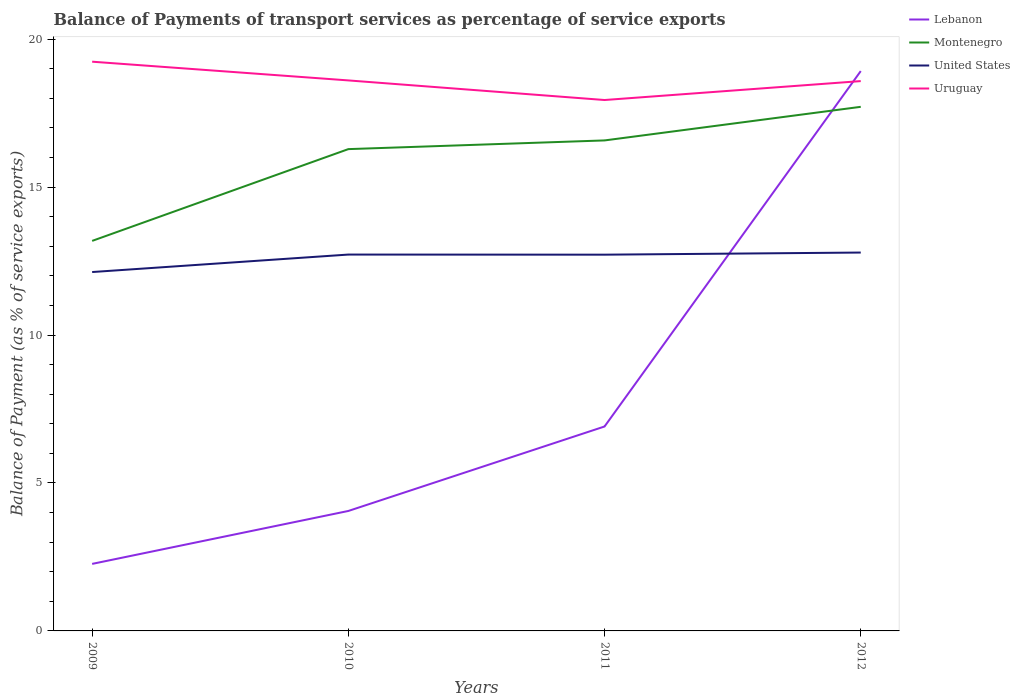Does the line corresponding to Montenegro intersect with the line corresponding to United States?
Your response must be concise. No. Is the number of lines equal to the number of legend labels?
Offer a very short reply. Yes. Across all years, what is the maximum balance of payments of transport services in Uruguay?
Keep it short and to the point. 17.94. In which year was the balance of payments of transport services in Montenegro maximum?
Your answer should be compact. 2009. What is the total balance of payments of transport services in Montenegro in the graph?
Your answer should be compact. -1.14. What is the difference between the highest and the second highest balance of payments of transport services in Montenegro?
Provide a short and direct response. 4.53. Is the balance of payments of transport services in Montenegro strictly greater than the balance of payments of transport services in Uruguay over the years?
Ensure brevity in your answer.  Yes. Are the values on the major ticks of Y-axis written in scientific E-notation?
Your answer should be compact. No. Does the graph contain any zero values?
Ensure brevity in your answer.  No. Does the graph contain grids?
Keep it short and to the point. No. Where does the legend appear in the graph?
Ensure brevity in your answer.  Top right. How many legend labels are there?
Offer a very short reply. 4. What is the title of the graph?
Your response must be concise. Balance of Payments of transport services as percentage of service exports. What is the label or title of the X-axis?
Your answer should be very brief. Years. What is the label or title of the Y-axis?
Provide a succinct answer. Balance of Payment (as % of service exports). What is the Balance of Payment (as % of service exports) of Lebanon in 2009?
Offer a very short reply. 2.27. What is the Balance of Payment (as % of service exports) of Montenegro in 2009?
Provide a short and direct response. 13.18. What is the Balance of Payment (as % of service exports) in United States in 2009?
Ensure brevity in your answer.  12.13. What is the Balance of Payment (as % of service exports) of Uruguay in 2009?
Offer a very short reply. 19.24. What is the Balance of Payment (as % of service exports) of Lebanon in 2010?
Provide a short and direct response. 4.05. What is the Balance of Payment (as % of service exports) of Montenegro in 2010?
Offer a terse response. 16.28. What is the Balance of Payment (as % of service exports) in United States in 2010?
Offer a very short reply. 12.72. What is the Balance of Payment (as % of service exports) of Uruguay in 2010?
Offer a very short reply. 18.61. What is the Balance of Payment (as % of service exports) of Lebanon in 2011?
Provide a succinct answer. 6.91. What is the Balance of Payment (as % of service exports) in Montenegro in 2011?
Offer a terse response. 16.58. What is the Balance of Payment (as % of service exports) of United States in 2011?
Give a very brief answer. 12.72. What is the Balance of Payment (as % of service exports) of Uruguay in 2011?
Give a very brief answer. 17.94. What is the Balance of Payment (as % of service exports) of Lebanon in 2012?
Keep it short and to the point. 18.92. What is the Balance of Payment (as % of service exports) of Montenegro in 2012?
Your answer should be very brief. 17.71. What is the Balance of Payment (as % of service exports) of United States in 2012?
Provide a short and direct response. 12.79. What is the Balance of Payment (as % of service exports) of Uruguay in 2012?
Give a very brief answer. 18.58. Across all years, what is the maximum Balance of Payment (as % of service exports) of Lebanon?
Offer a terse response. 18.92. Across all years, what is the maximum Balance of Payment (as % of service exports) in Montenegro?
Provide a succinct answer. 17.71. Across all years, what is the maximum Balance of Payment (as % of service exports) of United States?
Your answer should be very brief. 12.79. Across all years, what is the maximum Balance of Payment (as % of service exports) of Uruguay?
Provide a short and direct response. 19.24. Across all years, what is the minimum Balance of Payment (as % of service exports) of Lebanon?
Your answer should be very brief. 2.27. Across all years, what is the minimum Balance of Payment (as % of service exports) of Montenegro?
Your answer should be very brief. 13.18. Across all years, what is the minimum Balance of Payment (as % of service exports) in United States?
Give a very brief answer. 12.13. Across all years, what is the minimum Balance of Payment (as % of service exports) of Uruguay?
Make the answer very short. 17.94. What is the total Balance of Payment (as % of service exports) in Lebanon in the graph?
Offer a very short reply. 32.15. What is the total Balance of Payment (as % of service exports) of Montenegro in the graph?
Offer a very short reply. 63.76. What is the total Balance of Payment (as % of service exports) of United States in the graph?
Provide a succinct answer. 50.35. What is the total Balance of Payment (as % of service exports) in Uruguay in the graph?
Provide a succinct answer. 74.37. What is the difference between the Balance of Payment (as % of service exports) of Lebanon in 2009 and that in 2010?
Keep it short and to the point. -1.79. What is the difference between the Balance of Payment (as % of service exports) of Montenegro in 2009 and that in 2010?
Offer a terse response. -3.1. What is the difference between the Balance of Payment (as % of service exports) of United States in 2009 and that in 2010?
Keep it short and to the point. -0.59. What is the difference between the Balance of Payment (as % of service exports) in Uruguay in 2009 and that in 2010?
Your response must be concise. 0.63. What is the difference between the Balance of Payment (as % of service exports) in Lebanon in 2009 and that in 2011?
Give a very brief answer. -4.64. What is the difference between the Balance of Payment (as % of service exports) of Montenegro in 2009 and that in 2011?
Ensure brevity in your answer.  -3.4. What is the difference between the Balance of Payment (as % of service exports) in United States in 2009 and that in 2011?
Ensure brevity in your answer.  -0.59. What is the difference between the Balance of Payment (as % of service exports) in Uruguay in 2009 and that in 2011?
Provide a succinct answer. 1.3. What is the difference between the Balance of Payment (as % of service exports) in Lebanon in 2009 and that in 2012?
Provide a short and direct response. -16.66. What is the difference between the Balance of Payment (as % of service exports) in Montenegro in 2009 and that in 2012?
Make the answer very short. -4.53. What is the difference between the Balance of Payment (as % of service exports) in United States in 2009 and that in 2012?
Give a very brief answer. -0.66. What is the difference between the Balance of Payment (as % of service exports) of Uruguay in 2009 and that in 2012?
Your answer should be compact. 0.66. What is the difference between the Balance of Payment (as % of service exports) of Lebanon in 2010 and that in 2011?
Your answer should be compact. -2.85. What is the difference between the Balance of Payment (as % of service exports) in Montenegro in 2010 and that in 2011?
Your answer should be very brief. -0.29. What is the difference between the Balance of Payment (as % of service exports) in United States in 2010 and that in 2011?
Provide a succinct answer. 0. What is the difference between the Balance of Payment (as % of service exports) of Uruguay in 2010 and that in 2011?
Your answer should be compact. 0.66. What is the difference between the Balance of Payment (as % of service exports) of Lebanon in 2010 and that in 2012?
Give a very brief answer. -14.87. What is the difference between the Balance of Payment (as % of service exports) of Montenegro in 2010 and that in 2012?
Give a very brief answer. -1.43. What is the difference between the Balance of Payment (as % of service exports) in United States in 2010 and that in 2012?
Your answer should be very brief. -0.07. What is the difference between the Balance of Payment (as % of service exports) of Uruguay in 2010 and that in 2012?
Provide a short and direct response. 0.02. What is the difference between the Balance of Payment (as % of service exports) in Lebanon in 2011 and that in 2012?
Make the answer very short. -12.01. What is the difference between the Balance of Payment (as % of service exports) in Montenegro in 2011 and that in 2012?
Your answer should be very brief. -1.14. What is the difference between the Balance of Payment (as % of service exports) in United States in 2011 and that in 2012?
Provide a short and direct response. -0.07. What is the difference between the Balance of Payment (as % of service exports) of Uruguay in 2011 and that in 2012?
Offer a very short reply. -0.64. What is the difference between the Balance of Payment (as % of service exports) of Lebanon in 2009 and the Balance of Payment (as % of service exports) of Montenegro in 2010?
Provide a succinct answer. -14.02. What is the difference between the Balance of Payment (as % of service exports) in Lebanon in 2009 and the Balance of Payment (as % of service exports) in United States in 2010?
Keep it short and to the point. -10.45. What is the difference between the Balance of Payment (as % of service exports) of Lebanon in 2009 and the Balance of Payment (as % of service exports) of Uruguay in 2010?
Offer a very short reply. -16.34. What is the difference between the Balance of Payment (as % of service exports) in Montenegro in 2009 and the Balance of Payment (as % of service exports) in United States in 2010?
Keep it short and to the point. 0.46. What is the difference between the Balance of Payment (as % of service exports) in Montenegro in 2009 and the Balance of Payment (as % of service exports) in Uruguay in 2010?
Give a very brief answer. -5.42. What is the difference between the Balance of Payment (as % of service exports) of United States in 2009 and the Balance of Payment (as % of service exports) of Uruguay in 2010?
Make the answer very short. -6.48. What is the difference between the Balance of Payment (as % of service exports) of Lebanon in 2009 and the Balance of Payment (as % of service exports) of Montenegro in 2011?
Your answer should be compact. -14.31. What is the difference between the Balance of Payment (as % of service exports) of Lebanon in 2009 and the Balance of Payment (as % of service exports) of United States in 2011?
Keep it short and to the point. -10.45. What is the difference between the Balance of Payment (as % of service exports) of Lebanon in 2009 and the Balance of Payment (as % of service exports) of Uruguay in 2011?
Your answer should be very brief. -15.68. What is the difference between the Balance of Payment (as % of service exports) in Montenegro in 2009 and the Balance of Payment (as % of service exports) in United States in 2011?
Your answer should be very brief. 0.47. What is the difference between the Balance of Payment (as % of service exports) in Montenegro in 2009 and the Balance of Payment (as % of service exports) in Uruguay in 2011?
Provide a short and direct response. -4.76. What is the difference between the Balance of Payment (as % of service exports) in United States in 2009 and the Balance of Payment (as % of service exports) in Uruguay in 2011?
Your answer should be very brief. -5.81. What is the difference between the Balance of Payment (as % of service exports) of Lebanon in 2009 and the Balance of Payment (as % of service exports) of Montenegro in 2012?
Give a very brief answer. -15.45. What is the difference between the Balance of Payment (as % of service exports) of Lebanon in 2009 and the Balance of Payment (as % of service exports) of United States in 2012?
Offer a terse response. -10.52. What is the difference between the Balance of Payment (as % of service exports) of Lebanon in 2009 and the Balance of Payment (as % of service exports) of Uruguay in 2012?
Offer a very short reply. -16.32. What is the difference between the Balance of Payment (as % of service exports) of Montenegro in 2009 and the Balance of Payment (as % of service exports) of United States in 2012?
Your answer should be compact. 0.39. What is the difference between the Balance of Payment (as % of service exports) of Montenegro in 2009 and the Balance of Payment (as % of service exports) of Uruguay in 2012?
Give a very brief answer. -5.4. What is the difference between the Balance of Payment (as % of service exports) in United States in 2009 and the Balance of Payment (as % of service exports) in Uruguay in 2012?
Give a very brief answer. -6.45. What is the difference between the Balance of Payment (as % of service exports) in Lebanon in 2010 and the Balance of Payment (as % of service exports) in Montenegro in 2011?
Provide a succinct answer. -12.52. What is the difference between the Balance of Payment (as % of service exports) of Lebanon in 2010 and the Balance of Payment (as % of service exports) of United States in 2011?
Provide a succinct answer. -8.66. What is the difference between the Balance of Payment (as % of service exports) in Lebanon in 2010 and the Balance of Payment (as % of service exports) in Uruguay in 2011?
Keep it short and to the point. -13.89. What is the difference between the Balance of Payment (as % of service exports) of Montenegro in 2010 and the Balance of Payment (as % of service exports) of United States in 2011?
Your answer should be compact. 3.57. What is the difference between the Balance of Payment (as % of service exports) of Montenegro in 2010 and the Balance of Payment (as % of service exports) of Uruguay in 2011?
Provide a succinct answer. -1.66. What is the difference between the Balance of Payment (as % of service exports) in United States in 2010 and the Balance of Payment (as % of service exports) in Uruguay in 2011?
Provide a short and direct response. -5.22. What is the difference between the Balance of Payment (as % of service exports) of Lebanon in 2010 and the Balance of Payment (as % of service exports) of Montenegro in 2012?
Make the answer very short. -13.66. What is the difference between the Balance of Payment (as % of service exports) in Lebanon in 2010 and the Balance of Payment (as % of service exports) in United States in 2012?
Provide a short and direct response. -8.73. What is the difference between the Balance of Payment (as % of service exports) in Lebanon in 2010 and the Balance of Payment (as % of service exports) in Uruguay in 2012?
Your response must be concise. -14.53. What is the difference between the Balance of Payment (as % of service exports) of Montenegro in 2010 and the Balance of Payment (as % of service exports) of United States in 2012?
Keep it short and to the point. 3.5. What is the difference between the Balance of Payment (as % of service exports) of Montenegro in 2010 and the Balance of Payment (as % of service exports) of Uruguay in 2012?
Your answer should be very brief. -2.3. What is the difference between the Balance of Payment (as % of service exports) in United States in 2010 and the Balance of Payment (as % of service exports) in Uruguay in 2012?
Your answer should be compact. -5.86. What is the difference between the Balance of Payment (as % of service exports) of Lebanon in 2011 and the Balance of Payment (as % of service exports) of Montenegro in 2012?
Keep it short and to the point. -10.8. What is the difference between the Balance of Payment (as % of service exports) of Lebanon in 2011 and the Balance of Payment (as % of service exports) of United States in 2012?
Provide a succinct answer. -5.88. What is the difference between the Balance of Payment (as % of service exports) of Lebanon in 2011 and the Balance of Payment (as % of service exports) of Uruguay in 2012?
Ensure brevity in your answer.  -11.67. What is the difference between the Balance of Payment (as % of service exports) of Montenegro in 2011 and the Balance of Payment (as % of service exports) of United States in 2012?
Ensure brevity in your answer.  3.79. What is the difference between the Balance of Payment (as % of service exports) of Montenegro in 2011 and the Balance of Payment (as % of service exports) of Uruguay in 2012?
Offer a terse response. -2.01. What is the difference between the Balance of Payment (as % of service exports) in United States in 2011 and the Balance of Payment (as % of service exports) in Uruguay in 2012?
Keep it short and to the point. -5.87. What is the average Balance of Payment (as % of service exports) of Lebanon per year?
Your answer should be very brief. 8.04. What is the average Balance of Payment (as % of service exports) in Montenegro per year?
Ensure brevity in your answer.  15.94. What is the average Balance of Payment (as % of service exports) of United States per year?
Keep it short and to the point. 12.59. What is the average Balance of Payment (as % of service exports) in Uruguay per year?
Make the answer very short. 18.59. In the year 2009, what is the difference between the Balance of Payment (as % of service exports) in Lebanon and Balance of Payment (as % of service exports) in Montenegro?
Offer a terse response. -10.92. In the year 2009, what is the difference between the Balance of Payment (as % of service exports) in Lebanon and Balance of Payment (as % of service exports) in United States?
Offer a very short reply. -9.86. In the year 2009, what is the difference between the Balance of Payment (as % of service exports) of Lebanon and Balance of Payment (as % of service exports) of Uruguay?
Provide a short and direct response. -16.97. In the year 2009, what is the difference between the Balance of Payment (as % of service exports) in Montenegro and Balance of Payment (as % of service exports) in United States?
Your answer should be very brief. 1.05. In the year 2009, what is the difference between the Balance of Payment (as % of service exports) of Montenegro and Balance of Payment (as % of service exports) of Uruguay?
Give a very brief answer. -6.06. In the year 2009, what is the difference between the Balance of Payment (as % of service exports) in United States and Balance of Payment (as % of service exports) in Uruguay?
Make the answer very short. -7.11. In the year 2010, what is the difference between the Balance of Payment (as % of service exports) in Lebanon and Balance of Payment (as % of service exports) in Montenegro?
Your answer should be compact. -12.23. In the year 2010, what is the difference between the Balance of Payment (as % of service exports) in Lebanon and Balance of Payment (as % of service exports) in United States?
Your answer should be very brief. -8.67. In the year 2010, what is the difference between the Balance of Payment (as % of service exports) of Lebanon and Balance of Payment (as % of service exports) of Uruguay?
Ensure brevity in your answer.  -14.55. In the year 2010, what is the difference between the Balance of Payment (as % of service exports) of Montenegro and Balance of Payment (as % of service exports) of United States?
Your response must be concise. 3.56. In the year 2010, what is the difference between the Balance of Payment (as % of service exports) in Montenegro and Balance of Payment (as % of service exports) in Uruguay?
Offer a very short reply. -2.32. In the year 2010, what is the difference between the Balance of Payment (as % of service exports) of United States and Balance of Payment (as % of service exports) of Uruguay?
Keep it short and to the point. -5.89. In the year 2011, what is the difference between the Balance of Payment (as % of service exports) in Lebanon and Balance of Payment (as % of service exports) in Montenegro?
Ensure brevity in your answer.  -9.67. In the year 2011, what is the difference between the Balance of Payment (as % of service exports) of Lebanon and Balance of Payment (as % of service exports) of United States?
Make the answer very short. -5.81. In the year 2011, what is the difference between the Balance of Payment (as % of service exports) of Lebanon and Balance of Payment (as % of service exports) of Uruguay?
Offer a terse response. -11.03. In the year 2011, what is the difference between the Balance of Payment (as % of service exports) in Montenegro and Balance of Payment (as % of service exports) in United States?
Keep it short and to the point. 3.86. In the year 2011, what is the difference between the Balance of Payment (as % of service exports) in Montenegro and Balance of Payment (as % of service exports) in Uruguay?
Provide a succinct answer. -1.37. In the year 2011, what is the difference between the Balance of Payment (as % of service exports) of United States and Balance of Payment (as % of service exports) of Uruguay?
Provide a succinct answer. -5.23. In the year 2012, what is the difference between the Balance of Payment (as % of service exports) of Lebanon and Balance of Payment (as % of service exports) of Montenegro?
Your answer should be very brief. 1.21. In the year 2012, what is the difference between the Balance of Payment (as % of service exports) in Lebanon and Balance of Payment (as % of service exports) in United States?
Keep it short and to the point. 6.13. In the year 2012, what is the difference between the Balance of Payment (as % of service exports) in Lebanon and Balance of Payment (as % of service exports) in Uruguay?
Ensure brevity in your answer.  0.34. In the year 2012, what is the difference between the Balance of Payment (as % of service exports) of Montenegro and Balance of Payment (as % of service exports) of United States?
Your response must be concise. 4.92. In the year 2012, what is the difference between the Balance of Payment (as % of service exports) in Montenegro and Balance of Payment (as % of service exports) in Uruguay?
Provide a short and direct response. -0.87. In the year 2012, what is the difference between the Balance of Payment (as % of service exports) of United States and Balance of Payment (as % of service exports) of Uruguay?
Make the answer very short. -5.79. What is the ratio of the Balance of Payment (as % of service exports) in Lebanon in 2009 to that in 2010?
Make the answer very short. 0.56. What is the ratio of the Balance of Payment (as % of service exports) in Montenegro in 2009 to that in 2010?
Make the answer very short. 0.81. What is the ratio of the Balance of Payment (as % of service exports) in United States in 2009 to that in 2010?
Offer a very short reply. 0.95. What is the ratio of the Balance of Payment (as % of service exports) of Uruguay in 2009 to that in 2010?
Your answer should be compact. 1.03. What is the ratio of the Balance of Payment (as % of service exports) of Lebanon in 2009 to that in 2011?
Offer a very short reply. 0.33. What is the ratio of the Balance of Payment (as % of service exports) in Montenegro in 2009 to that in 2011?
Provide a succinct answer. 0.8. What is the ratio of the Balance of Payment (as % of service exports) of United States in 2009 to that in 2011?
Ensure brevity in your answer.  0.95. What is the ratio of the Balance of Payment (as % of service exports) of Uruguay in 2009 to that in 2011?
Give a very brief answer. 1.07. What is the ratio of the Balance of Payment (as % of service exports) of Lebanon in 2009 to that in 2012?
Provide a short and direct response. 0.12. What is the ratio of the Balance of Payment (as % of service exports) in Montenegro in 2009 to that in 2012?
Provide a short and direct response. 0.74. What is the ratio of the Balance of Payment (as % of service exports) of United States in 2009 to that in 2012?
Provide a short and direct response. 0.95. What is the ratio of the Balance of Payment (as % of service exports) of Uruguay in 2009 to that in 2012?
Ensure brevity in your answer.  1.04. What is the ratio of the Balance of Payment (as % of service exports) of Lebanon in 2010 to that in 2011?
Give a very brief answer. 0.59. What is the ratio of the Balance of Payment (as % of service exports) of Montenegro in 2010 to that in 2011?
Offer a very short reply. 0.98. What is the ratio of the Balance of Payment (as % of service exports) of United States in 2010 to that in 2011?
Your answer should be compact. 1. What is the ratio of the Balance of Payment (as % of service exports) in Uruguay in 2010 to that in 2011?
Your response must be concise. 1.04. What is the ratio of the Balance of Payment (as % of service exports) of Lebanon in 2010 to that in 2012?
Ensure brevity in your answer.  0.21. What is the ratio of the Balance of Payment (as % of service exports) of Montenegro in 2010 to that in 2012?
Make the answer very short. 0.92. What is the ratio of the Balance of Payment (as % of service exports) in United States in 2010 to that in 2012?
Give a very brief answer. 0.99. What is the ratio of the Balance of Payment (as % of service exports) of Uruguay in 2010 to that in 2012?
Keep it short and to the point. 1. What is the ratio of the Balance of Payment (as % of service exports) in Lebanon in 2011 to that in 2012?
Your answer should be very brief. 0.37. What is the ratio of the Balance of Payment (as % of service exports) of Montenegro in 2011 to that in 2012?
Provide a succinct answer. 0.94. What is the ratio of the Balance of Payment (as % of service exports) in United States in 2011 to that in 2012?
Make the answer very short. 0.99. What is the ratio of the Balance of Payment (as % of service exports) in Uruguay in 2011 to that in 2012?
Keep it short and to the point. 0.97. What is the difference between the highest and the second highest Balance of Payment (as % of service exports) in Lebanon?
Give a very brief answer. 12.01. What is the difference between the highest and the second highest Balance of Payment (as % of service exports) in Montenegro?
Make the answer very short. 1.14. What is the difference between the highest and the second highest Balance of Payment (as % of service exports) in United States?
Your response must be concise. 0.07. What is the difference between the highest and the second highest Balance of Payment (as % of service exports) of Uruguay?
Offer a terse response. 0.63. What is the difference between the highest and the lowest Balance of Payment (as % of service exports) of Lebanon?
Your answer should be compact. 16.66. What is the difference between the highest and the lowest Balance of Payment (as % of service exports) of Montenegro?
Give a very brief answer. 4.53. What is the difference between the highest and the lowest Balance of Payment (as % of service exports) of United States?
Offer a terse response. 0.66. What is the difference between the highest and the lowest Balance of Payment (as % of service exports) of Uruguay?
Make the answer very short. 1.3. 